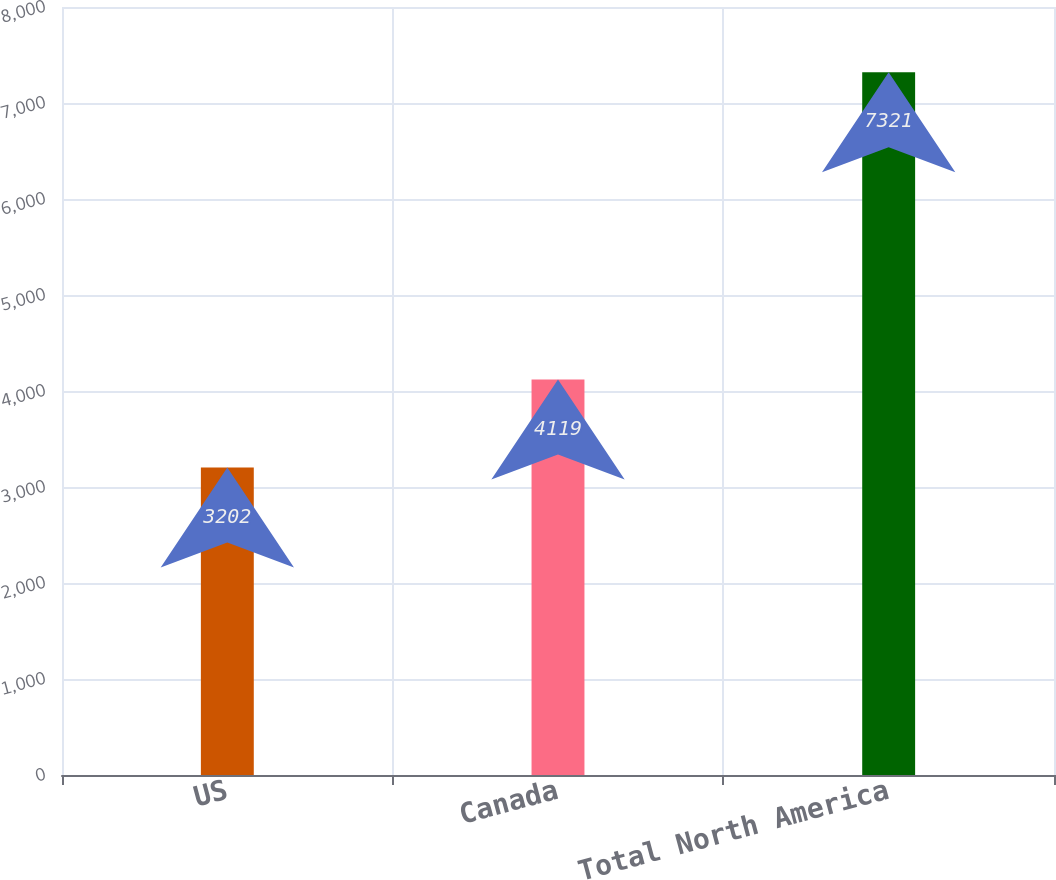Convert chart to OTSL. <chart><loc_0><loc_0><loc_500><loc_500><bar_chart><fcel>US<fcel>Canada<fcel>Total North America<nl><fcel>3202<fcel>4119<fcel>7321<nl></chart> 